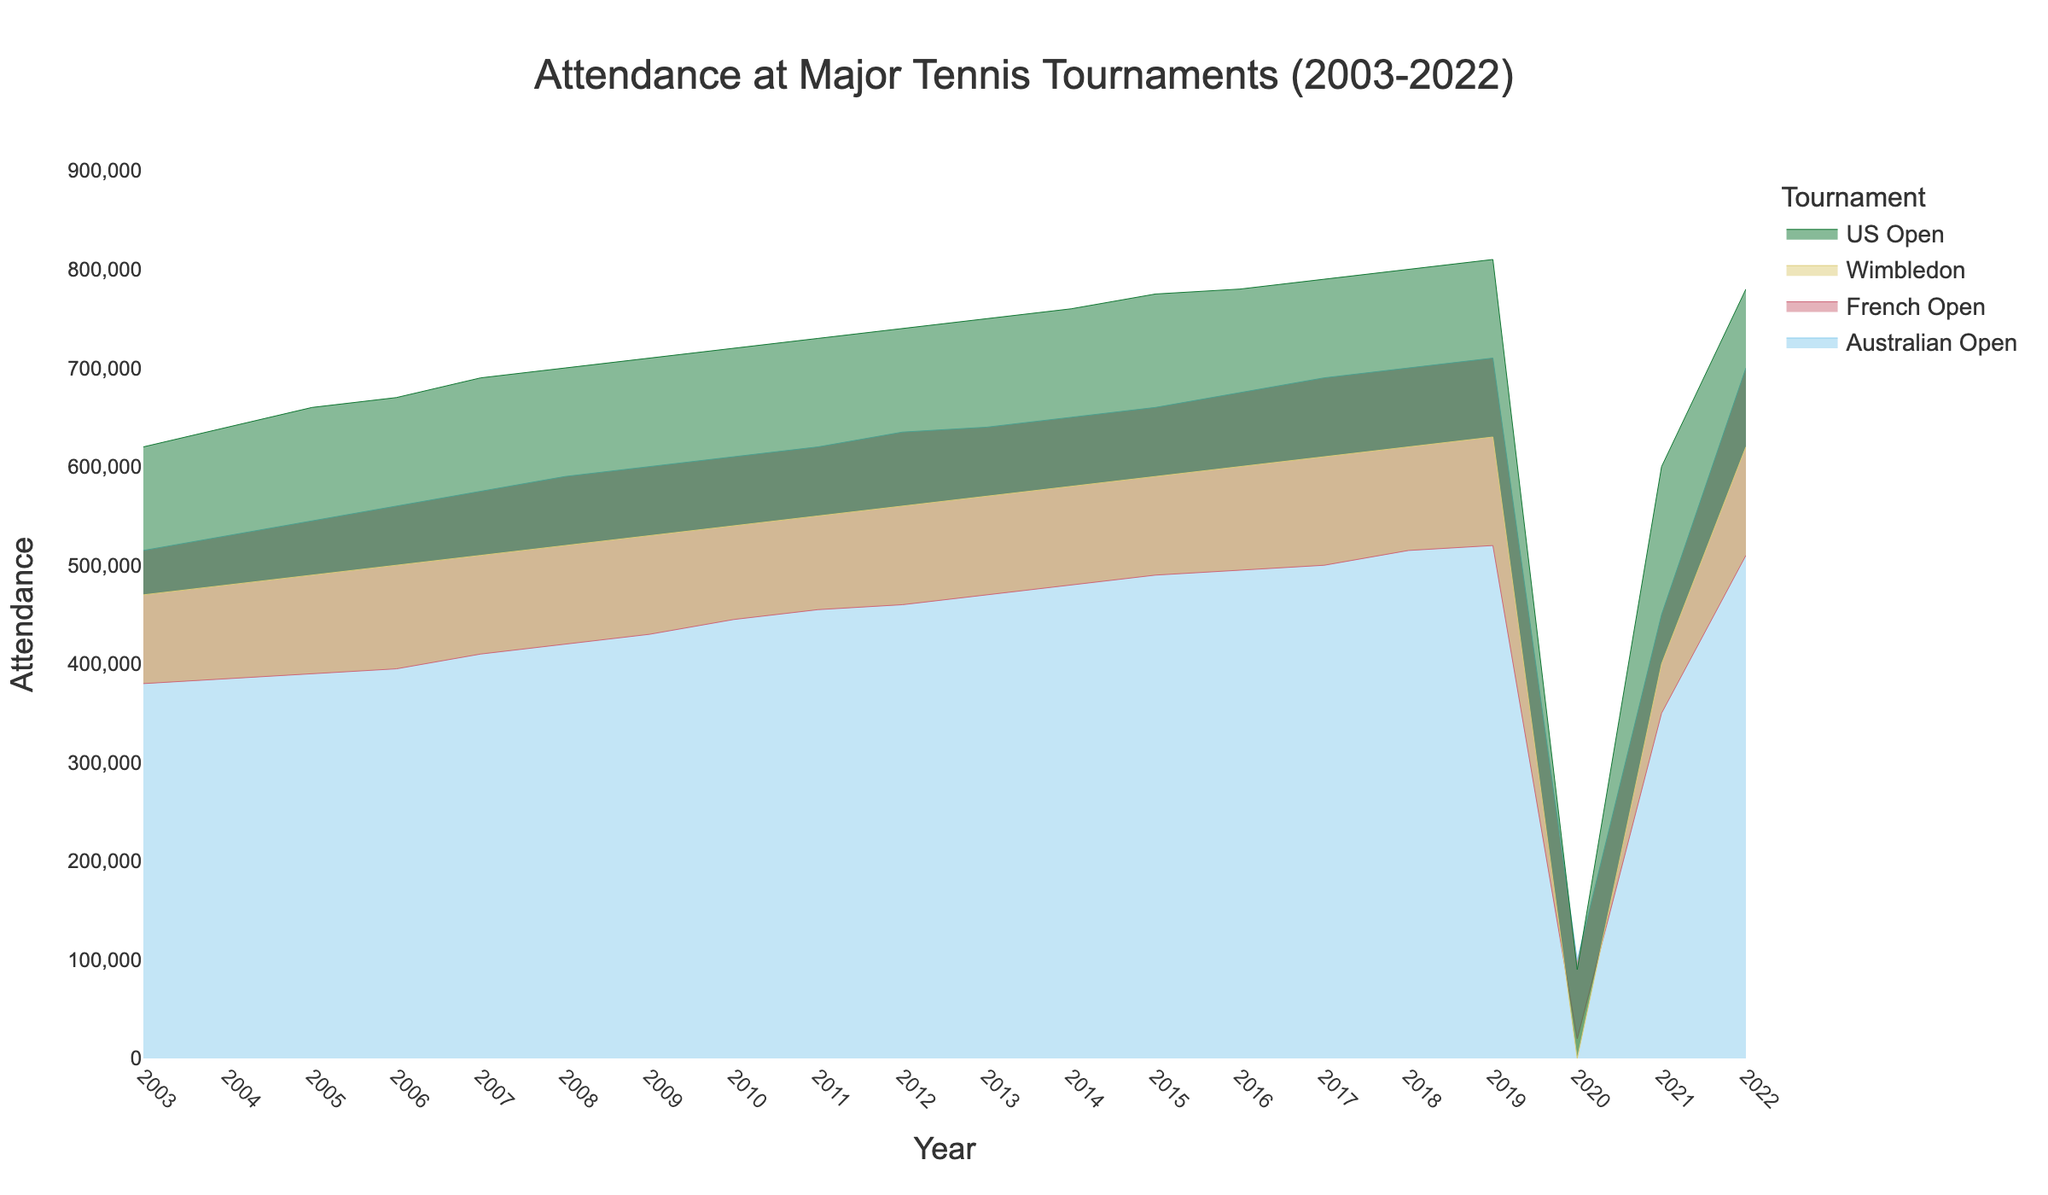what is the total attendance of the Australian Open in 2022? To find the answer, locate the value for the Australian Open in 2022 from the chart and sum it directly since it's only asking for one year. The attendance in 2022 is 700000.
Answer: 700000 In which year did Wimbledon have zero attendance? Find the point where Wimbledon's attendance is marked as 0. According to the chart, this occurred in 2020.
Answer: 2020 What is the difference in attendance between the US Open and the French Open in 2019? Look at the attendance values for both the US Open and the French Open in 2019 and subtract the latter from the former. The values are 810,000 for the US Open and 520000 for the French Open. So, 810000 - 520000 = 290000
Answer: 290000 How did the attendance for major tournaments change in 2020 compared to 2019? Compare the attendance values for each tournament in 2019 and 2020. Attendance significantly decreased for all tournaments in 2020 compared to 2019, with Wimbledon having 0 attendance due to cancellation.
Answer: Decreased drastically Which tournament had the highest attendance in 2015? Compare the attendance values for all four tournaments in 2015. The values are 660,000 for the Australian Open, 490,000 for the French Open, 590,000 for Wimbledon, and 775,000 for the US Open. The US Open has the highest attendance.
Answer: US Open What was the approximate average attendance for the French Open between 2007 and 2011? Sum the attendance values for the French Open from 2007 to 2011, then divide by the number of years (5). The values are 410000, 420000, 430000, 445000, 455000. So, the average attendance = (410000 + 420000 + 430000 + 445000 + 455000) / 5 = 432000
Answer: 432000 In which years did the Australian Open see the highest incremental increase in attendance? Identify the point where the difference between consecutive years is the largest for the Australian Open. The largest incremental increases are found by observing the jumps in values for each year, which is between 2019 and 2020 (710000 to 100000), making it a special case, but the next largest would be between 2015 and 2016 (660000 to 675000)
Answer: 2019-2020 and 2015-2016 How does the attendance trend for the US Open between 2003 and 2019 appear? Examine the attendance values for the US Open from 2003 through 2019. The trend shows a steady increase in attendance each year until 2019.
Answer: Steady increase 